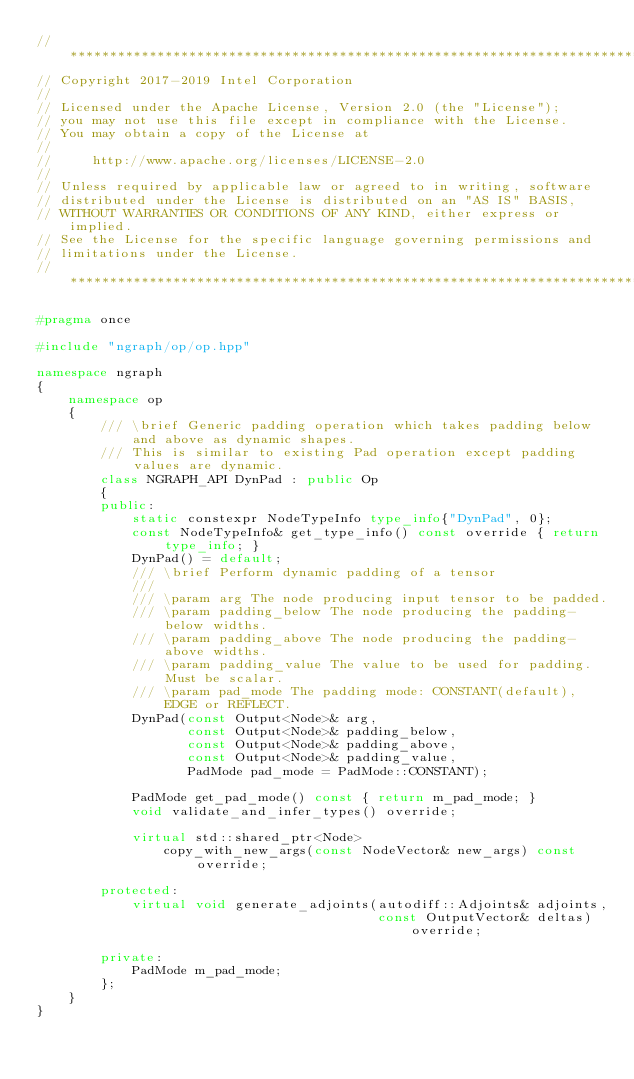<code> <loc_0><loc_0><loc_500><loc_500><_C++_>//*****************************************************************************
// Copyright 2017-2019 Intel Corporation
//
// Licensed under the Apache License, Version 2.0 (the "License");
// you may not use this file except in compliance with the License.
// You may obtain a copy of the License at
//
//     http://www.apache.org/licenses/LICENSE-2.0
//
// Unless required by applicable law or agreed to in writing, software
// distributed under the License is distributed on an "AS IS" BASIS,
// WITHOUT WARRANTIES OR CONDITIONS OF ANY KIND, either express or implied.
// See the License for the specific language governing permissions and
// limitations under the License.
//*****************************************************************************

#pragma once

#include "ngraph/op/op.hpp"

namespace ngraph
{
    namespace op
    {
        /// \brief Generic padding operation which takes padding below and above as dynamic shapes.
        /// This is similar to existing Pad operation except padding values are dynamic.
        class NGRAPH_API DynPad : public Op
        {
        public:
            static constexpr NodeTypeInfo type_info{"DynPad", 0};
            const NodeTypeInfo& get_type_info() const override { return type_info; }
            DynPad() = default;
            /// \brief Perform dynamic padding of a tensor
            ///
            /// \param arg The node producing input tensor to be padded.
            /// \param padding_below The node producing the padding-below widths.
            /// \param padding_above The node producing the padding-above widths.
            /// \param padding_value The value to be used for padding. Must be scalar.
            /// \param pad_mode The padding mode: CONSTANT(default), EDGE or REFLECT.
            DynPad(const Output<Node>& arg,
                   const Output<Node>& padding_below,
                   const Output<Node>& padding_above,
                   const Output<Node>& padding_value,
                   PadMode pad_mode = PadMode::CONSTANT);

            PadMode get_pad_mode() const { return m_pad_mode; }
            void validate_and_infer_types() override;

            virtual std::shared_ptr<Node>
                copy_with_new_args(const NodeVector& new_args) const override;

        protected:
            virtual void generate_adjoints(autodiff::Adjoints& adjoints,
                                           const OutputVector& deltas) override;

        private:
            PadMode m_pad_mode;
        };
    }
}
</code> 